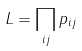Convert formula to latex. <formula><loc_0><loc_0><loc_500><loc_500>L = \prod _ { i j } p _ { i j }</formula> 